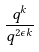Convert formula to latex. <formula><loc_0><loc_0><loc_500><loc_500>\frac { q ^ { k } } { q ^ { 2 \epsilon k } }</formula> 